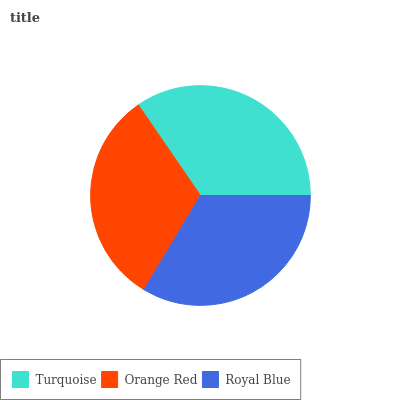Is Orange Red the minimum?
Answer yes or no. Yes. Is Turquoise the maximum?
Answer yes or no. Yes. Is Royal Blue the minimum?
Answer yes or no. No. Is Royal Blue the maximum?
Answer yes or no. No. Is Royal Blue greater than Orange Red?
Answer yes or no. Yes. Is Orange Red less than Royal Blue?
Answer yes or no. Yes. Is Orange Red greater than Royal Blue?
Answer yes or no. No. Is Royal Blue less than Orange Red?
Answer yes or no. No. Is Royal Blue the high median?
Answer yes or no. Yes. Is Royal Blue the low median?
Answer yes or no. Yes. Is Turquoise the high median?
Answer yes or no. No. Is Turquoise the low median?
Answer yes or no. No. 